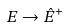Convert formula to latex. <formula><loc_0><loc_0><loc_500><loc_500>E \rightarrow \hat { E } ^ { + }</formula> 